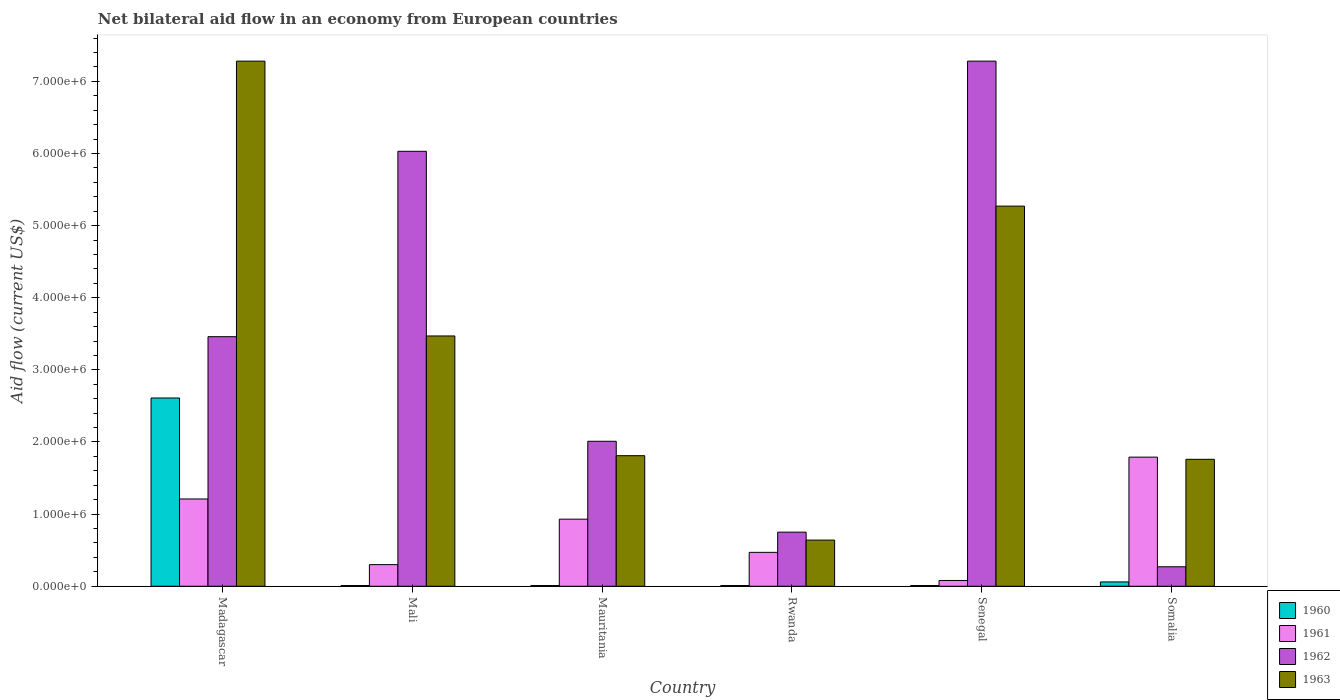Are the number of bars on each tick of the X-axis equal?
Give a very brief answer. Yes. How many bars are there on the 4th tick from the left?
Keep it short and to the point. 4. What is the label of the 2nd group of bars from the left?
Make the answer very short. Mali. Across all countries, what is the maximum net bilateral aid flow in 1962?
Your answer should be very brief. 7.28e+06. Across all countries, what is the minimum net bilateral aid flow in 1961?
Ensure brevity in your answer.  8.00e+04. In which country was the net bilateral aid flow in 1960 maximum?
Ensure brevity in your answer.  Madagascar. In which country was the net bilateral aid flow in 1962 minimum?
Offer a terse response. Somalia. What is the total net bilateral aid flow in 1960 in the graph?
Your answer should be very brief. 2.71e+06. What is the difference between the net bilateral aid flow in 1961 in Madagascar and that in Somalia?
Provide a short and direct response. -5.80e+05. What is the difference between the net bilateral aid flow in 1962 in Mauritania and the net bilateral aid flow in 1960 in Rwanda?
Make the answer very short. 2.00e+06. What is the average net bilateral aid flow in 1960 per country?
Offer a terse response. 4.52e+05. What is the difference between the net bilateral aid flow of/in 1961 and net bilateral aid flow of/in 1962 in Rwanda?
Make the answer very short. -2.80e+05. In how many countries, is the net bilateral aid flow in 1962 greater than 1400000 US$?
Make the answer very short. 4. What is the ratio of the net bilateral aid flow in 1963 in Madagascar to that in Senegal?
Your answer should be compact. 1.38. What is the difference between the highest and the second highest net bilateral aid flow in 1961?
Offer a very short reply. 5.80e+05. What is the difference between the highest and the lowest net bilateral aid flow in 1961?
Provide a succinct answer. 1.71e+06. What does the 3rd bar from the left in Rwanda represents?
Keep it short and to the point. 1962. Is it the case that in every country, the sum of the net bilateral aid flow in 1961 and net bilateral aid flow in 1960 is greater than the net bilateral aid flow in 1962?
Offer a terse response. No. How many bars are there?
Provide a succinct answer. 24. Are all the bars in the graph horizontal?
Your response must be concise. No. How many countries are there in the graph?
Make the answer very short. 6. Does the graph contain grids?
Your response must be concise. No. Where does the legend appear in the graph?
Give a very brief answer. Bottom right. How are the legend labels stacked?
Your answer should be compact. Vertical. What is the title of the graph?
Your answer should be compact. Net bilateral aid flow in an economy from European countries. Does "1998" appear as one of the legend labels in the graph?
Your answer should be compact. No. What is the label or title of the X-axis?
Your answer should be very brief. Country. What is the Aid flow (current US$) in 1960 in Madagascar?
Provide a short and direct response. 2.61e+06. What is the Aid flow (current US$) in 1961 in Madagascar?
Give a very brief answer. 1.21e+06. What is the Aid flow (current US$) in 1962 in Madagascar?
Your answer should be very brief. 3.46e+06. What is the Aid flow (current US$) of 1963 in Madagascar?
Offer a terse response. 7.28e+06. What is the Aid flow (current US$) in 1960 in Mali?
Your answer should be very brief. 10000. What is the Aid flow (current US$) in 1962 in Mali?
Your response must be concise. 6.03e+06. What is the Aid flow (current US$) of 1963 in Mali?
Your response must be concise. 3.47e+06. What is the Aid flow (current US$) of 1961 in Mauritania?
Give a very brief answer. 9.30e+05. What is the Aid flow (current US$) in 1962 in Mauritania?
Provide a succinct answer. 2.01e+06. What is the Aid flow (current US$) in 1963 in Mauritania?
Your answer should be very brief. 1.81e+06. What is the Aid flow (current US$) of 1962 in Rwanda?
Your answer should be compact. 7.50e+05. What is the Aid flow (current US$) of 1963 in Rwanda?
Offer a very short reply. 6.40e+05. What is the Aid flow (current US$) in 1962 in Senegal?
Offer a terse response. 7.28e+06. What is the Aid flow (current US$) in 1963 in Senegal?
Offer a very short reply. 5.27e+06. What is the Aid flow (current US$) of 1961 in Somalia?
Ensure brevity in your answer.  1.79e+06. What is the Aid flow (current US$) of 1963 in Somalia?
Your answer should be very brief. 1.76e+06. Across all countries, what is the maximum Aid flow (current US$) in 1960?
Provide a short and direct response. 2.61e+06. Across all countries, what is the maximum Aid flow (current US$) of 1961?
Give a very brief answer. 1.79e+06. Across all countries, what is the maximum Aid flow (current US$) of 1962?
Give a very brief answer. 7.28e+06. Across all countries, what is the maximum Aid flow (current US$) of 1963?
Offer a terse response. 7.28e+06. Across all countries, what is the minimum Aid flow (current US$) in 1961?
Keep it short and to the point. 8.00e+04. Across all countries, what is the minimum Aid flow (current US$) in 1963?
Provide a short and direct response. 6.40e+05. What is the total Aid flow (current US$) of 1960 in the graph?
Make the answer very short. 2.71e+06. What is the total Aid flow (current US$) of 1961 in the graph?
Your answer should be very brief. 4.78e+06. What is the total Aid flow (current US$) in 1962 in the graph?
Offer a terse response. 1.98e+07. What is the total Aid flow (current US$) of 1963 in the graph?
Offer a very short reply. 2.02e+07. What is the difference between the Aid flow (current US$) of 1960 in Madagascar and that in Mali?
Your answer should be compact. 2.60e+06. What is the difference between the Aid flow (current US$) of 1961 in Madagascar and that in Mali?
Offer a terse response. 9.10e+05. What is the difference between the Aid flow (current US$) of 1962 in Madagascar and that in Mali?
Provide a succinct answer. -2.57e+06. What is the difference between the Aid flow (current US$) of 1963 in Madagascar and that in Mali?
Make the answer very short. 3.81e+06. What is the difference between the Aid flow (current US$) of 1960 in Madagascar and that in Mauritania?
Keep it short and to the point. 2.60e+06. What is the difference between the Aid flow (current US$) in 1962 in Madagascar and that in Mauritania?
Ensure brevity in your answer.  1.45e+06. What is the difference between the Aid flow (current US$) of 1963 in Madagascar and that in Mauritania?
Ensure brevity in your answer.  5.47e+06. What is the difference between the Aid flow (current US$) of 1960 in Madagascar and that in Rwanda?
Your answer should be very brief. 2.60e+06. What is the difference between the Aid flow (current US$) in 1961 in Madagascar and that in Rwanda?
Provide a short and direct response. 7.40e+05. What is the difference between the Aid flow (current US$) in 1962 in Madagascar and that in Rwanda?
Give a very brief answer. 2.71e+06. What is the difference between the Aid flow (current US$) in 1963 in Madagascar and that in Rwanda?
Make the answer very short. 6.64e+06. What is the difference between the Aid flow (current US$) in 1960 in Madagascar and that in Senegal?
Your answer should be very brief. 2.60e+06. What is the difference between the Aid flow (current US$) of 1961 in Madagascar and that in Senegal?
Provide a succinct answer. 1.13e+06. What is the difference between the Aid flow (current US$) in 1962 in Madagascar and that in Senegal?
Provide a succinct answer. -3.82e+06. What is the difference between the Aid flow (current US$) in 1963 in Madagascar and that in Senegal?
Keep it short and to the point. 2.01e+06. What is the difference between the Aid flow (current US$) of 1960 in Madagascar and that in Somalia?
Provide a short and direct response. 2.55e+06. What is the difference between the Aid flow (current US$) in 1961 in Madagascar and that in Somalia?
Ensure brevity in your answer.  -5.80e+05. What is the difference between the Aid flow (current US$) of 1962 in Madagascar and that in Somalia?
Give a very brief answer. 3.19e+06. What is the difference between the Aid flow (current US$) of 1963 in Madagascar and that in Somalia?
Offer a very short reply. 5.52e+06. What is the difference between the Aid flow (current US$) in 1960 in Mali and that in Mauritania?
Give a very brief answer. 0. What is the difference between the Aid flow (current US$) in 1961 in Mali and that in Mauritania?
Provide a succinct answer. -6.30e+05. What is the difference between the Aid flow (current US$) of 1962 in Mali and that in Mauritania?
Make the answer very short. 4.02e+06. What is the difference between the Aid flow (current US$) of 1963 in Mali and that in Mauritania?
Make the answer very short. 1.66e+06. What is the difference between the Aid flow (current US$) of 1960 in Mali and that in Rwanda?
Your answer should be very brief. 0. What is the difference between the Aid flow (current US$) in 1961 in Mali and that in Rwanda?
Provide a succinct answer. -1.70e+05. What is the difference between the Aid flow (current US$) of 1962 in Mali and that in Rwanda?
Keep it short and to the point. 5.28e+06. What is the difference between the Aid flow (current US$) of 1963 in Mali and that in Rwanda?
Your answer should be compact. 2.83e+06. What is the difference between the Aid flow (current US$) of 1962 in Mali and that in Senegal?
Give a very brief answer. -1.25e+06. What is the difference between the Aid flow (current US$) in 1963 in Mali and that in Senegal?
Provide a short and direct response. -1.80e+06. What is the difference between the Aid flow (current US$) of 1961 in Mali and that in Somalia?
Provide a short and direct response. -1.49e+06. What is the difference between the Aid flow (current US$) of 1962 in Mali and that in Somalia?
Offer a very short reply. 5.76e+06. What is the difference between the Aid flow (current US$) of 1963 in Mali and that in Somalia?
Your response must be concise. 1.71e+06. What is the difference between the Aid flow (current US$) of 1961 in Mauritania and that in Rwanda?
Offer a terse response. 4.60e+05. What is the difference between the Aid flow (current US$) in 1962 in Mauritania and that in Rwanda?
Your answer should be compact. 1.26e+06. What is the difference between the Aid flow (current US$) of 1963 in Mauritania and that in Rwanda?
Your answer should be compact. 1.17e+06. What is the difference between the Aid flow (current US$) of 1960 in Mauritania and that in Senegal?
Your answer should be very brief. 0. What is the difference between the Aid flow (current US$) of 1961 in Mauritania and that in Senegal?
Make the answer very short. 8.50e+05. What is the difference between the Aid flow (current US$) of 1962 in Mauritania and that in Senegal?
Provide a short and direct response. -5.27e+06. What is the difference between the Aid flow (current US$) of 1963 in Mauritania and that in Senegal?
Make the answer very short. -3.46e+06. What is the difference between the Aid flow (current US$) of 1961 in Mauritania and that in Somalia?
Offer a very short reply. -8.60e+05. What is the difference between the Aid flow (current US$) of 1962 in Mauritania and that in Somalia?
Make the answer very short. 1.74e+06. What is the difference between the Aid flow (current US$) of 1960 in Rwanda and that in Senegal?
Your answer should be very brief. 0. What is the difference between the Aid flow (current US$) in 1961 in Rwanda and that in Senegal?
Provide a succinct answer. 3.90e+05. What is the difference between the Aid flow (current US$) in 1962 in Rwanda and that in Senegal?
Keep it short and to the point. -6.53e+06. What is the difference between the Aid flow (current US$) of 1963 in Rwanda and that in Senegal?
Make the answer very short. -4.63e+06. What is the difference between the Aid flow (current US$) of 1960 in Rwanda and that in Somalia?
Give a very brief answer. -5.00e+04. What is the difference between the Aid flow (current US$) in 1961 in Rwanda and that in Somalia?
Offer a terse response. -1.32e+06. What is the difference between the Aid flow (current US$) of 1963 in Rwanda and that in Somalia?
Your response must be concise. -1.12e+06. What is the difference between the Aid flow (current US$) in 1961 in Senegal and that in Somalia?
Offer a terse response. -1.71e+06. What is the difference between the Aid flow (current US$) in 1962 in Senegal and that in Somalia?
Provide a succinct answer. 7.01e+06. What is the difference between the Aid flow (current US$) in 1963 in Senegal and that in Somalia?
Keep it short and to the point. 3.51e+06. What is the difference between the Aid flow (current US$) of 1960 in Madagascar and the Aid flow (current US$) of 1961 in Mali?
Provide a succinct answer. 2.31e+06. What is the difference between the Aid flow (current US$) in 1960 in Madagascar and the Aid flow (current US$) in 1962 in Mali?
Provide a short and direct response. -3.42e+06. What is the difference between the Aid flow (current US$) in 1960 in Madagascar and the Aid flow (current US$) in 1963 in Mali?
Offer a terse response. -8.60e+05. What is the difference between the Aid flow (current US$) of 1961 in Madagascar and the Aid flow (current US$) of 1962 in Mali?
Offer a terse response. -4.82e+06. What is the difference between the Aid flow (current US$) in 1961 in Madagascar and the Aid flow (current US$) in 1963 in Mali?
Give a very brief answer. -2.26e+06. What is the difference between the Aid flow (current US$) of 1962 in Madagascar and the Aid flow (current US$) of 1963 in Mali?
Ensure brevity in your answer.  -10000. What is the difference between the Aid flow (current US$) in 1960 in Madagascar and the Aid flow (current US$) in 1961 in Mauritania?
Give a very brief answer. 1.68e+06. What is the difference between the Aid flow (current US$) of 1960 in Madagascar and the Aid flow (current US$) of 1962 in Mauritania?
Keep it short and to the point. 6.00e+05. What is the difference between the Aid flow (current US$) of 1961 in Madagascar and the Aid flow (current US$) of 1962 in Mauritania?
Offer a terse response. -8.00e+05. What is the difference between the Aid flow (current US$) of 1961 in Madagascar and the Aid flow (current US$) of 1963 in Mauritania?
Your answer should be very brief. -6.00e+05. What is the difference between the Aid flow (current US$) in 1962 in Madagascar and the Aid flow (current US$) in 1963 in Mauritania?
Your answer should be compact. 1.65e+06. What is the difference between the Aid flow (current US$) of 1960 in Madagascar and the Aid flow (current US$) of 1961 in Rwanda?
Make the answer very short. 2.14e+06. What is the difference between the Aid flow (current US$) of 1960 in Madagascar and the Aid flow (current US$) of 1962 in Rwanda?
Provide a succinct answer. 1.86e+06. What is the difference between the Aid flow (current US$) in 1960 in Madagascar and the Aid flow (current US$) in 1963 in Rwanda?
Your response must be concise. 1.97e+06. What is the difference between the Aid flow (current US$) of 1961 in Madagascar and the Aid flow (current US$) of 1963 in Rwanda?
Offer a terse response. 5.70e+05. What is the difference between the Aid flow (current US$) in 1962 in Madagascar and the Aid flow (current US$) in 1963 in Rwanda?
Provide a short and direct response. 2.82e+06. What is the difference between the Aid flow (current US$) in 1960 in Madagascar and the Aid flow (current US$) in 1961 in Senegal?
Ensure brevity in your answer.  2.53e+06. What is the difference between the Aid flow (current US$) in 1960 in Madagascar and the Aid flow (current US$) in 1962 in Senegal?
Offer a very short reply. -4.67e+06. What is the difference between the Aid flow (current US$) in 1960 in Madagascar and the Aid flow (current US$) in 1963 in Senegal?
Make the answer very short. -2.66e+06. What is the difference between the Aid flow (current US$) of 1961 in Madagascar and the Aid flow (current US$) of 1962 in Senegal?
Offer a terse response. -6.07e+06. What is the difference between the Aid flow (current US$) in 1961 in Madagascar and the Aid flow (current US$) in 1963 in Senegal?
Provide a succinct answer. -4.06e+06. What is the difference between the Aid flow (current US$) in 1962 in Madagascar and the Aid flow (current US$) in 1963 in Senegal?
Your response must be concise. -1.81e+06. What is the difference between the Aid flow (current US$) of 1960 in Madagascar and the Aid flow (current US$) of 1961 in Somalia?
Your answer should be compact. 8.20e+05. What is the difference between the Aid flow (current US$) in 1960 in Madagascar and the Aid flow (current US$) in 1962 in Somalia?
Give a very brief answer. 2.34e+06. What is the difference between the Aid flow (current US$) of 1960 in Madagascar and the Aid flow (current US$) of 1963 in Somalia?
Give a very brief answer. 8.50e+05. What is the difference between the Aid flow (current US$) in 1961 in Madagascar and the Aid flow (current US$) in 1962 in Somalia?
Ensure brevity in your answer.  9.40e+05. What is the difference between the Aid flow (current US$) of 1961 in Madagascar and the Aid flow (current US$) of 1963 in Somalia?
Ensure brevity in your answer.  -5.50e+05. What is the difference between the Aid flow (current US$) in 1962 in Madagascar and the Aid flow (current US$) in 1963 in Somalia?
Provide a succinct answer. 1.70e+06. What is the difference between the Aid flow (current US$) in 1960 in Mali and the Aid flow (current US$) in 1961 in Mauritania?
Your answer should be very brief. -9.20e+05. What is the difference between the Aid flow (current US$) of 1960 in Mali and the Aid flow (current US$) of 1963 in Mauritania?
Your answer should be very brief. -1.80e+06. What is the difference between the Aid flow (current US$) of 1961 in Mali and the Aid flow (current US$) of 1962 in Mauritania?
Provide a short and direct response. -1.71e+06. What is the difference between the Aid flow (current US$) of 1961 in Mali and the Aid flow (current US$) of 1963 in Mauritania?
Provide a short and direct response. -1.51e+06. What is the difference between the Aid flow (current US$) of 1962 in Mali and the Aid flow (current US$) of 1963 in Mauritania?
Offer a terse response. 4.22e+06. What is the difference between the Aid flow (current US$) in 1960 in Mali and the Aid flow (current US$) in 1961 in Rwanda?
Your answer should be compact. -4.60e+05. What is the difference between the Aid flow (current US$) of 1960 in Mali and the Aid flow (current US$) of 1962 in Rwanda?
Offer a very short reply. -7.40e+05. What is the difference between the Aid flow (current US$) of 1960 in Mali and the Aid flow (current US$) of 1963 in Rwanda?
Ensure brevity in your answer.  -6.30e+05. What is the difference between the Aid flow (current US$) of 1961 in Mali and the Aid flow (current US$) of 1962 in Rwanda?
Offer a terse response. -4.50e+05. What is the difference between the Aid flow (current US$) in 1962 in Mali and the Aid flow (current US$) in 1963 in Rwanda?
Ensure brevity in your answer.  5.39e+06. What is the difference between the Aid flow (current US$) in 1960 in Mali and the Aid flow (current US$) in 1962 in Senegal?
Your answer should be compact. -7.27e+06. What is the difference between the Aid flow (current US$) of 1960 in Mali and the Aid flow (current US$) of 1963 in Senegal?
Your answer should be very brief. -5.26e+06. What is the difference between the Aid flow (current US$) of 1961 in Mali and the Aid flow (current US$) of 1962 in Senegal?
Your answer should be very brief. -6.98e+06. What is the difference between the Aid flow (current US$) of 1961 in Mali and the Aid flow (current US$) of 1963 in Senegal?
Provide a short and direct response. -4.97e+06. What is the difference between the Aid flow (current US$) in 1962 in Mali and the Aid flow (current US$) in 1963 in Senegal?
Offer a terse response. 7.60e+05. What is the difference between the Aid flow (current US$) of 1960 in Mali and the Aid flow (current US$) of 1961 in Somalia?
Provide a succinct answer. -1.78e+06. What is the difference between the Aid flow (current US$) of 1960 in Mali and the Aid flow (current US$) of 1963 in Somalia?
Your answer should be very brief. -1.75e+06. What is the difference between the Aid flow (current US$) in 1961 in Mali and the Aid flow (current US$) in 1963 in Somalia?
Make the answer very short. -1.46e+06. What is the difference between the Aid flow (current US$) in 1962 in Mali and the Aid flow (current US$) in 1963 in Somalia?
Your answer should be very brief. 4.27e+06. What is the difference between the Aid flow (current US$) in 1960 in Mauritania and the Aid flow (current US$) in 1961 in Rwanda?
Your answer should be compact. -4.60e+05. What is the difference between the Aid flow (current US$) of 1960 in Mauritania and the Aid flow (current US$) of 1962 in Rwanda?
Provide a short and direct response. -7.40e+05. What is the difference between the Aid flow (current US$) in 1960 in Mauritania and the Aid flow (current US$) in 1963 in Rwanda?
Ensure brevity in your answer.  -6.30e+05. What is the difference between the Aid flow (current US$) of 1961 in Mauritania and the Aid flow (current US$) of 1962 in Rwanda?
Offer a terse response. 1.80e+05. What is the difference between the Aid flow (current US$) in 1962 in Mauritania and the Aid flow (current US$) in 1963 in Rwanda?
Your answer should be compact. 1.37e+06. What is the difference between the Aid flow (current US$) in 1960 in Mauritania and the Aid flow (current US$) in 1962 in Senegal?
Provide a short and direct response. -7.27e+06. What is the difference between the Aid flow (current US$) of 1960 in Mauritania and the Aid flow (current US$) of 1963 in Senegal?
Keep it short and to the point. -5.26e+06. What is the difference between the Aid flow (current US$) in 1961 in Mauritania and the Aid flow (current US$) in 1962 in Senegal?
Your response must be concise. -6.35e+06. What is the difference between the Aid flow (current US$) of 1961 in Mauritania and the Aid flow (current US$) of 1963 in Senegal?
Keep it short and to the point. -4.34e+06. What is the difference between the Aid flow (current US$) of 1962 in Mauritania and the Aid flow (current US$) of 1963 in Senegal?
Provide a succinct answer. -3.26e+06. What is the difference between the Aid flow (current US$) in 1960 in Mauritania and the Aid flow (current US$) in 1961 in Somalia?
Offer a very short reply. -1.78e+06. What is the difference between the Aid flow (current US$) of 1960 in Mauritania and the Aid flow (current US$) of 1962 in Somalia?
Provide a short and direct response. -2.60e+05. What is the difference between the Aid flow (current US$) in 1960 in Mauritania and the Aid flow (current US$) in 1963 in Somalia?
Offer a terse response. -1.75e+06. What is the difference between the Aid flow (current US$) in 1961 in Mauritania and the Aid flow (current US$) in 1963 in Somalia?
Your answer should be compact. -8.30e+05. What is the difference between the Aid flow (current US$) in 1960 in Rwanda and the Aid flow (current US$) in 1961 in Senegal?
Ensure brevity in your answer.  -7.00e+04. What is the difference between the Aid flow (current US$) in 1960 in Rwanda and the Aid flow (current US$) in 1962 in Senegal?
Your response must be concise. -7.27e+06. What is the difference between the Aid flow (current US$) of 1960 in Rwanda and the Aid flow (current US$) of 1963 in Senegal?
Offer a terse response. -5.26e+06. What is the difference between the Aid flow (current US$) in 1961 in Rwanda and the Aid flow (current US$) in 1962 in Senegal?
Offer a very short reply. -6.81e+06. What is the difference between the Aid flow (current US$) of 1961 in Rwanda and the Aid flow (current US$) of 1963 in Senegal?
Ensure brevity in your answer.  -4.80e+06. What is the difference between the Aid flow (current US$) in 1962 in Rwanda and the Aid flow (current US$) in 1963 in Senegal?
Offer a terse response. -4.52e+06. What is the difference between the Aid flow (current US$) of 1960 in Rwanda and the Aid flow (current US$) of 1961 in Somalia?
Your answer should be very brief. -1.78e+06. What is the difference between the Aid flow (current US$) in 1960 in Rwanda and the Aid flow (current US$) in 1963 in Somalia?
Offer a very short reply. -1.75e+06. What is the difference between the Aid flow (current US$) of 1961 in Rwanda and the Aid flow (current US$) of 1963 in Somalia?
Your answer should be very brief. -1.29e+06. What is the difference between the Aid flow (current US$) of 1962 in Rwanda and the Aid flow (current US$) of 1963 in Somalia?
Offer a very short reply. -1.01e+06. What is the difference between the Aid flow (current US$) in 1960 in Senegal and the Aid flow (current US$) in 1961 in Somalia?
Provide a short and direct response. -1.78e+06. What is the difference between the Aid flow (current US$) in 1960 in Senegal and the Aid flow (current US$) in 1963 in Somalia?
Give a very brief answer. -1.75e+06. What is the difference between the Aid flow (current US$) of 1961 in Senegal and the Aid flow (current US$) of 1962 in Somalia?
Ensure brevity in your answer.  -1.90e+05. What is the difference between the Aid flow (current US$) in 1961 in Senegal and the Aid flow (current US$) in 1963 in Somalia?
Offer a terse response. -1.68e+06. What is the difference between the Aid flow (current US$) of 1962 in Senegal and the Aid flow (current US$) of 1963 in Somalia?
Provide a short and direct response. 5.52e+06. What is the average Aid flow (current US$) of 1960 per country?
Your answer should be very brief. 4.52e+05. What is the average Aid flow (current US$) in 1961 per country?
Provide a short and direct response. 7.97e+05. What is the average Aid flow (current US$) in 1962 per country?
Your response must be concise. 3.30e+06. What is the average Aid flow (current US$) in 1963 per country?
Provide a succinct answer. 3.37e+06. What is the difference between the Aid flow (current US$) in 1960 and Aid flow (current US$) in 1961 in Madagascar?
Keep it short and to the point. 1.40e+06. What is the difference between the Aid flow (current US$) of 1960 and Aid flow (current US$) of 1962 in Madagascar?
Offer a terse response. -8.50e+05. What is the difference between the Aid flow (current US$) of 1960 and Aid flow (current US$) of 1963 in Madagascar?
Keep it short and to the point. -4.67e+06. What is the difference between the Aid flow (current US$) in 1961 and Aid flow (current US$) in 1962 in Madagascar?
Ensure brevity in your answer.  -2.25e+06. What is the difference between the Aid flow (current US$) of 1961 and Aid flow (current US$) of 1963 in Madagascar?
Keep it short and to the point. -6.07e+06. What is the difference between the Aid flow (current US$) of 1962 and Aid flow (current US$) of 1963 in Madagascar?
Offer a terse response. -3.82e+06. What is the difference between the Aid flow (current US$) of 1960 and Aid flow (current US$) of 1962 in Mali?
Your response must be concise. -6.02e+06. What is the difference between the Aid flow (current US$) in 1960 and Aid flow (current US$) in 1963 in Mali?
Offer a very short reply. -3.46e+06. What is the difference between the Aid flow (current US$) of 1961 and Aid flow (current US$) of 1962 in Mali?
Make the answer very short. -5.73e+06. What is the difference between the Aid flow (current US$) of 1961 and Aid flow (current US$) of 1963 in Mali?
Your answer should be compact. -3.17e+06. What is the difference between the Aid flow (current US$) in 1962 and Aid flow (current US$) in 1963 in Mali?
Offer a very short reply. 2.56e+06. What is the difference between the Aid flow (current US$) in 1960 and Aid flow (current US$) in 1961 in Mauritania?
Your response must be concise. -9.20e+05. What is the difference between the Aid flow (current US$) in 1960 and Aid flow (current US$) in 1962 in Mauritania?
Offer a terse response. -2.00e+06. What is the difference between the Aid flow (current US$) of 1960 and Aid flow (current US$) of 1963 in Mauritania?
Make the answer very short. -1.80e+06. What is the difference between the Aid flow (current US$) in 1961 and Aid flow (current US$) in 1962 in Mauritania?
Offer a very short reply. -1.08e+06. What is the difference between the Aid flow (current US$) of 1961 and Aid flow (current US$) of 1963 in Mauritania?
Give a very brief answer. -8.80e+05. What is the difference between the Aid flow (current US$) of 1962 and Aid flow (current US$) of 1963 in Mauritania?
Provide a short and direct response. 2.00e+05. What is the difference between the Aid flow (current US$) of 1960 and Aid flow (current US$) of 1961 in Rwanda?
Offer a very short reply. -4.60e+05. What is the difference between the Aid flow (current US$) in 1960 and Aid flow (current US$) in 1962 in Rwanda?
Your response must be concise. -7.40e+05. What is the difference between the Aid flow (current US$) in 1960 and Aid flow (current US$) in 1963 in Rwanda?
Give a very brief answer. -6.30e+05. What is the difference between the Aid flow (current US$) in 1961 and Aid flow (current US$) in 1962 in Rwanda?
Provide a succinct answer. -2.80e+05. What is the difference between the Aid flow (current US$) of 1960 and Aid flow (current US$) of 1961 in Senegal?
Your response must be concise. -7.00e+04. What is the difference between the Aid flow (current US$) in 1960 and Aid flow (current US$) in 1962 in Senegal?
Ensure brevity in your answer.  -7.27e+06. What is the difference between the Aid flow (current US$) in 1960 and Aid flow (current US$) in 1963 in Senegal?
Provide a succinct answer. -5.26e+06. What is the difference between the Aid flow (current US$) in 1961 and Aid flow (current US$) in 1962 in Senegal?
Make the answer very short. -7.20e+06. What is the difference between the Aid flow (current US$) of 1961 and Aid flow (current US$) of 1963 in Senegal?
Ensure brevity in your answer.  -5.19e+06. What is the difference between the Aid flow (current US$) of 1962 and Aid flow (current US$) of 1963 in Senegal?
Your answer should be very brief. 2.01e+06. What is the difference between the Aid flow (current US$) of 1960 and Aid flow (current US$) of 1961 in Somalia?
Keep it short and to the point. -1.73e+06. What is the difference between the Aid flow (current US$) of 1960 and Aid flow (current US$) of 1963 in Somalia?
Your answer should be compact. -1.70e+06. What is the difference between the Aid flow (current US$) in 1961 and Aid flow (current US$) in 1962 in Somalia?
Ensure brevity in your answer.  1.52e+06. What is the difference between the Aid flow (current US$) of 1962 and Aid flow (current US$) of 1963 in Somalia?
Offer a very short reply. -1.49e+06. What is the ratio of the Aid flow (current US$) in 1960 in Madagascar to that in Mali?
Provide a succinct answer. 261. What is the ratio of the Aid flow (current US$) in 1961 in Madagascar to that in Mali?
Your answer should be very brief. 4.03. What is the ratio of the Aid flow (current US$) of 1962 in Madagascar to that in Mali?
Ensure brevity in your answer.  0.57. What is the ratio of the Aid flow (current US$) of 1963 in Madagascar to that in Mali?
Your answer should be compact. 2.1. What is the ratio of the Aid flow (current US$) of 1960 in Madagascar to that in Mauritania?
Ensure brevity in your answer.  261. What is the ratio of the Aid flow (current US$) of 1961 in Madagascar to that in Mauritania?
Make the answer very short. 1.3. What is the ratio of the Aid flow (current US$) in 1962 in Madagascar to that in Mauritania?
Your answer should be very brief. 1.72. What is the ratio of the Aid flow (current US$) in 1963 in Madagascar to that in Mauritania?
Offer a terse response. 4.02. What is the ratio of the Aid flow (current US$) of 1960 in Madagascar to that in Rwanda?
Provide a succinct answer. 261. What is the ratio of the Aid flow (current US$) in 1961 in Madagascar to that in Rwanda?
Offer a terse response. 2.57. What is the ratio of the Aid flow (current US$) in 1962 in Madagascar to that in Rwanda?
Your answer should be compact. 4.61. What is the ratio of the Aid flow (current US$) in 1963 in Madagascar to that in Rwanda?
Your answer should be compact. 11.38. What is the ratio of the Aid flow (current US$) in 1960 in Madagascar to that in Senegal?
Provide a short and direct response. 261. What is the ratio of the Aid flow (current US$) of 1961 in Madagascar to that in Senegal?
Make the answer very short. 15.12. What is the ratio of the Aid flow (current US$) in 1962 in Madagascar to that in Senegal?
Your answer should be very brief. 0.48. What is the ratio of the Aid flow (current US$) in 1963 in Madagascar to that in Senegal?
Keep it short and to the point. 1.38. What is the ratio of the Aid flow (current US$) of 1960 in Madagascar to that in Somalia?
Offer a terse response. 43.5. What is the ratio of the Aid flow (current US$) of 1961 in Madagascar to that in Somalia?
Offer a very short reply. 0.68. What is the ratio of the Aid flow (current US$) of 1962 in Madagascar to that in Somalia?
Give a very brief answer. 12.81. What is the ratio of the Aid flow (current US$) in 1963 in Madagascar to that in Somalia?
Your answer should be compact. 4.14. What is the ratio of the Aid flow (current US$) in 1960 in Mali to that in Mauritania?
Give a very brief answer. 1. What is the ratio of the Aid flow (current US$) in 1961 in Mali to that in Mauritania?
Your answer should be very brief. 0.32. What is the ratio of the Aid flow (current US$) in 1963 in Mali to that in Mauritania?
Ensure brevity in your answer.  1.92. What is the ratio of the Aid flow (current US$) of 1960 in Mali to that in Rwanda?
Give a very brief answer. 1. What is the ratio of the Aid flow (current US$) of 1961 in Mali to that in Rwanda?
Your answer should be very brief. 0.64. What is the ratio of the Aid flow (current US$) of 1962 in Mali to that in Rwanda?
Your answer should be very brief. 8.04. What is the ratio of the Aid flow (current US$) of 1963 in Mali to that in Rwanda?
Your answer should be compact. 5.42. What is the ratio of the Aid flow (current US$) of 1961 in Mali to that in Senegal?
Your answer should be compact. 3.75. What is the ratio of the Aid flow (current US$) in 1962 in Mali to that in Senegal?
Offer a very short reply. 0.83. What is the ratio of the Aid flow (current US$) in 1963 in Mali to that in Senegal?
Ensure brevity in your answer.  0.66. What is the ratio of the Aid flow (current US$) in 1961 in Mali to that in Somalia?
Your response must be concise. 0.17. What is the ratio of the Aid flow (current US$) in 1962 in Mali to that in Somalia?
Ensure brevity in your answer.  22.33. What is the ratio of the Aid flow (current US$) in 1963 in Mali to that in Somalia?
Your answer should be compact. 1.97. What is the ratio of the Aid flow (current US$) of 1961 in Mauritania to that in Rwanda?
Offer a very short reply. 1.98. What is the ratio of the Aid flow (current US$) in 1962 in Mauritania to that in Rwanda?
Ensure brevity in your answer.  2.68. What is the ratio of the Aid flow (current US$) in 1963 in Mauritania to that in Rwanda?
Provide a succinct answer. 2.83. What is the ratio of the Aid flow (current US$) of 1961 in Mauritania to that in Senegal?
Offer a terse response. 11.62. What is the ratio of the Aid flow (current US$) of 1962 in Mauritania to that in Senegal?
Provide a succinct answer. 0.28. What is the ratio of the Aid flow (current US$) of 1963 in Mauritania to that in Senegal?
Ensure brevity in your answer.  0.34. What is the ratio of the Aid flow (current US$) in 1960 in Mauritania to that in Somalia?
Ensure brevity in your answer.  0.17. What is the ratio of the Aid flow (current US$) in 1961 in Mauritania to that in Somalia?
Keep it short and to the point. 0.52. What is the ratio of the Aid flow (current US$) of 1962 in Mauritania to that in Somalia?
Make the answer very short. 7.44. What is the ratio of the Aid flow (current US$) of 1963 in Mauritania to that in Somalia?
Provide a succinct answer. 1.03. What is the ratio of the Aid flow (current US$) in 1961 in Rwanda to that in Senegal?
Keep it short and to the point. 5.88. What is the ratio of the Aid flow (current US$) of 1962 in Rwanda to that in Senegal?
Your answer should be compact. 0.1. What is the ratio of the Aid flow (current US$) of 1963 in Rwanda to that in Senegal?
Your response must be concise. 0.12. What is the ratio of the Aid flow (current US$) of 1961 in Rwanda to that in Somalia?
Offer a very short reply. 0.26. What is the ratio of the Aid flow (current US$) of 1962 in Rwanda to that in Somalia?
Provide a short and direct response. 2.78. What is the ratio of the Aid flow (current US$) of 1963 in Rwanda to that in Somalia?
Offer a terse response. 0.36. What is the ratio of the Aid flow (current US$) in 1961 in Senegal to that in Somalia?
Make the answer very short. 0.04. What is the ratio of the Aid flow (current US$) in 1962 in Senegal to that in Somalia?
Keep it short and to the point. 26.96. What is the ratio of the Aid flow (current US$) in 1963 in Senegal to that in Somalia?
Offer a terse response. 2.99. What is the difference between the highest and the second highest Aid flow (current US$) of 1960?
Make the answer very short. 2.55e+06. What is the difference between the highest and the second highest Aid flow (current US$) in 1961?
Your response must be concise. 5.80e+05. What is the difference between the highest and the second highest Aid flow (current US$) of 1962?
Provide a short and direct response. 1.25e+06. What is the difference between the highest and the second highest Aid flow (current US$) in 1963?
Give a very brief answer. 2.01e+06. What is the difference between the highest and the lowest Aid flow (current US$) of 1960?
Your response must be concise. 2.60e+06. What is the difference between the highest and the lowest Aid flow (current US$) in 1961?
Provide a succinct answer. 1.71e+06. What is the difference between the highest and the lowest Aid flow (current US$) of 1962?
Keep it short and to the point. 7.01e+06. What is the difference between the highest and the lowest Aid flow (current US$) of 1963?
Your response must be concise. 6.64e+06. 